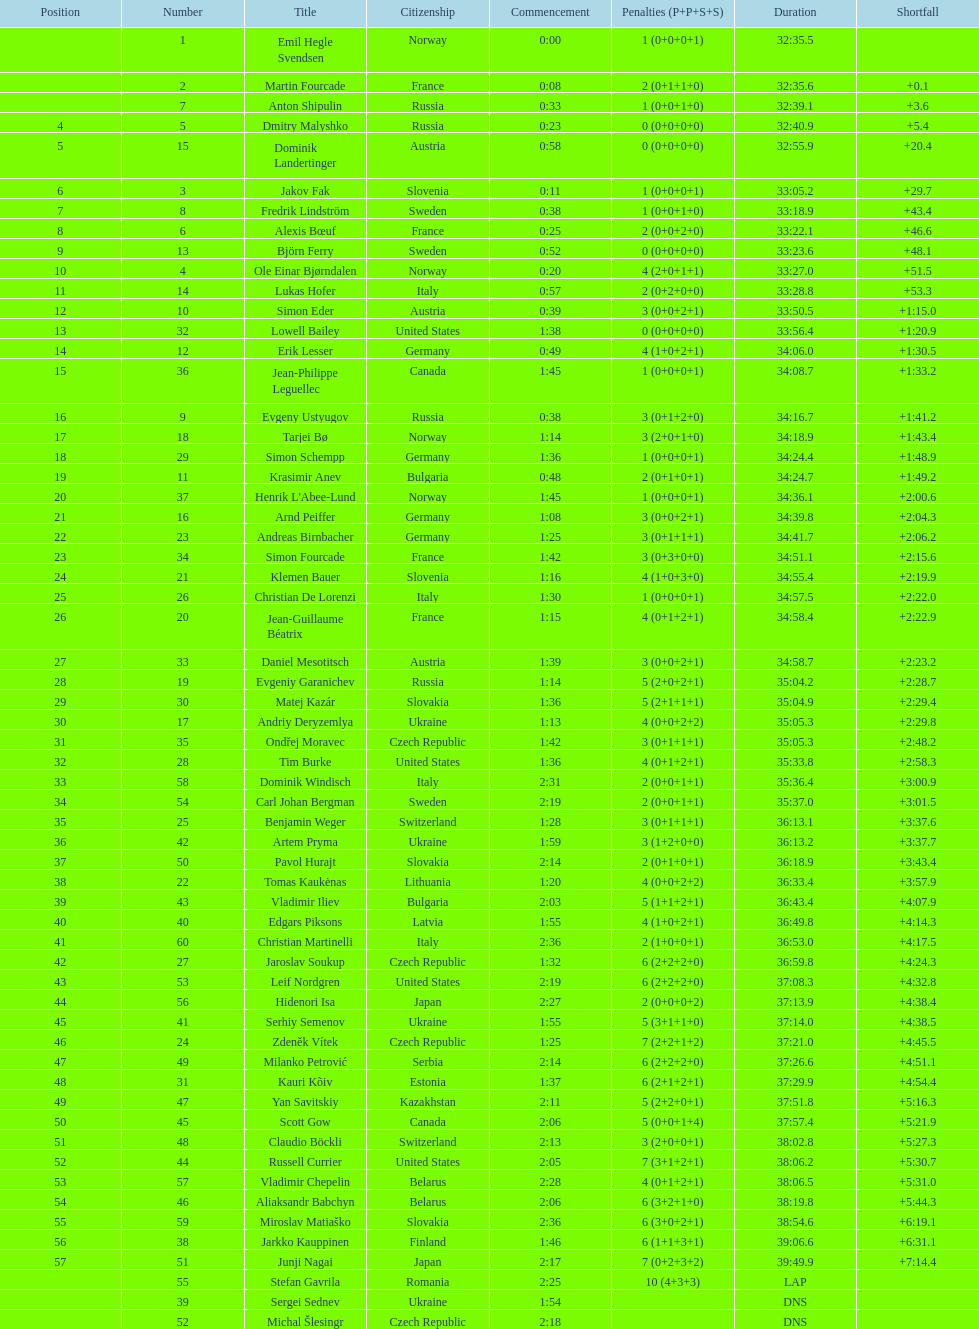How many united states competitors did not win medals? 4. 